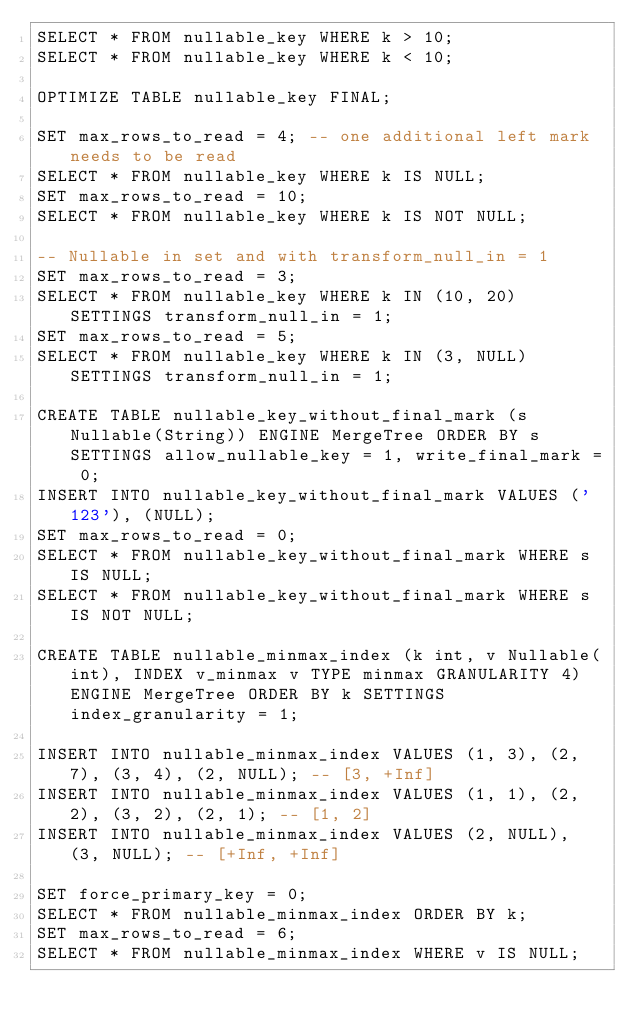<code> <loc_0><loc_0><loc_500><loc_500><_SQL_>SELECT * FROM nullable_key WHERE k > 10;
SELECT * FROM nullable_key WHERE k < 10;

OPTIMIZE TABLE nullable_key FINAL;

SET max_rows_to_read = 4; -- one additional left mark needs to be read
SELECT * FROM nullable_key WHERE k IS NULL;
SET max_rows_to_read = 10;
SELECT * FROM nullable_key WHERE k IS NOT NULL;

-- Nullable in set and with transform_null_in = 1
SET max_rows_to_read = 3;
SELECT * FROM nullable_key WHERE k IN (10, 20) SETTINGS transform_null_in = 1;
SET max_rows_to_read = 5;
SELECT * FROM nullable_key WHERE k IN (3, NULL) SETTINGS transform_null_in = 1;

CREATE TABLE nullable_key_without_final_mark (s Nullable(String)) ENGINE MergeTree ORDER BY s SETTINGS allow_nullable_key = 1, write_final_mark = 0;
INSERT INTO nullable_key_without_final_mark VALUES ('123'), (NULL);
SET max_rows_to_read = 0;
SELECT * FROM nullable_key_without_final_mark WHERE s IS NULL;
SELECT * FROM nullable_key_without_final_mark WHERE s IS NOT NULL;

CREATE TABLE nullable_minmax_index (k int, v Nullable(int), INDEX v_minmax v TYPE minmax GRANULARITY 4) ENGINE MergeTree ORDER BY k SETTINGS index_granularity = 1;

INSERT INTO nullable_minmax_index VALUES (1, 3), (2, 7), (3, 4), (2, NULL); -- [3, +Inf]
INSERT INTO nullable_minmax_index VALUES (1, 1), (2, 2), (3, 2), (2, 1); -- [1, 2]
INSERT INTO nullable_minmax_index VALUES (2, NULL), (3, NULL); -- [+Inf, +Inf]

SET force_primary_key = 0;
SELECT * FROM nullable_minmax_index ORDER BY k;
SET max_rows_to_read = 6;
SELECT * FROM nullable_minmax_index WHERE v IS NULL;</code> 